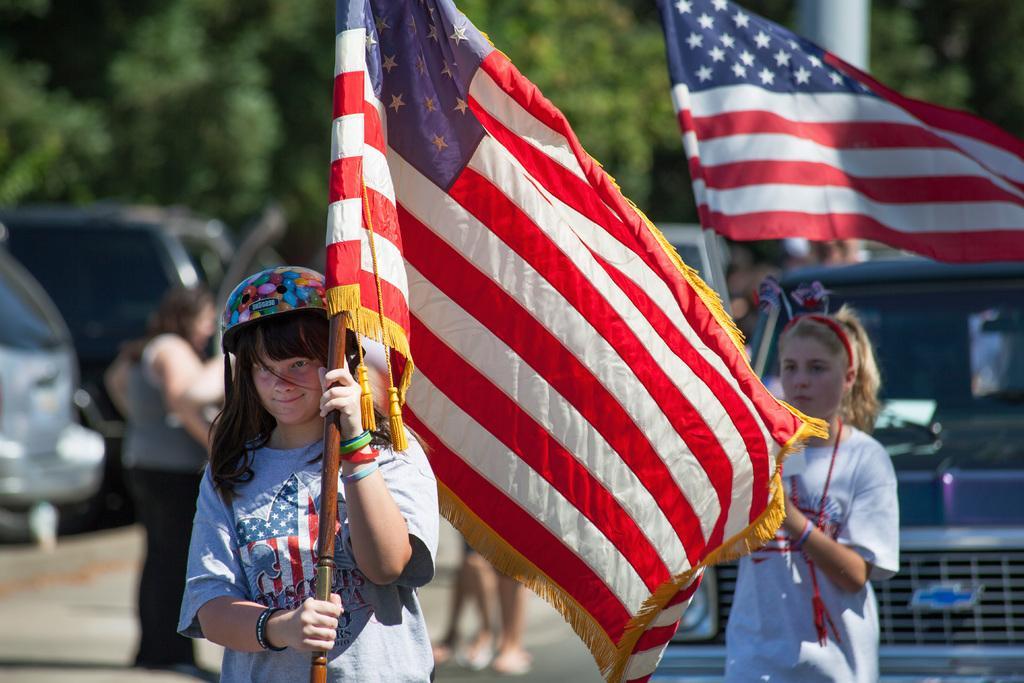Can you describe this image briefly? On the left side, there is a girl, holding a flag on a road. On the right side, there is another girl, holding a flag on the road. In the background, there are vehicles, persons and trees. 